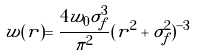<formula> <loc_0><loc_0><loc_500><loc_500>\tilde { w } ( r ) = \frac { 4 w _ { 0 } \sigma _ { f } ^ { 3 } } { \pi ^ { 2 } } ( r ^ { 2 } + \sigma _ { f } ^ { 2 } ) ^ { - 3 }</formula> 